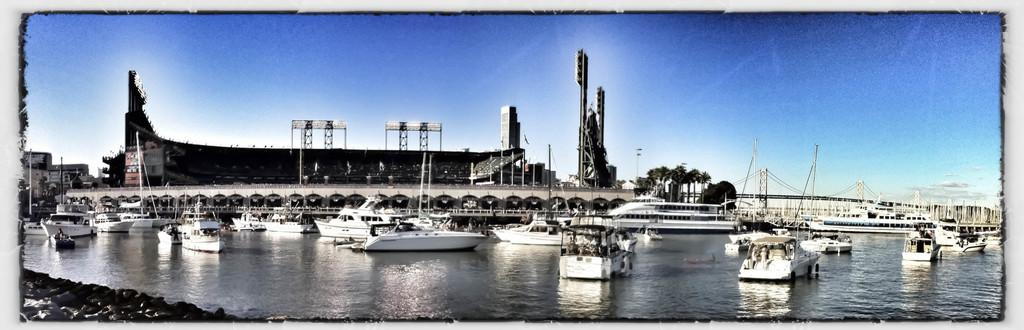What is in the front of the image? There is water in the front of the image. What is on the water? There are boats on the water. What can be seen in the background of the image? There are buildings, trees, a bridge, and the sky visible in the background of the image. What type of stem can be seen growing from the water in the image? There is no stem growing from the water in the image; it features boats on the water. What kind of wood is used to build the boats in the image? The image does not provide information about the materials used to build the boats. 